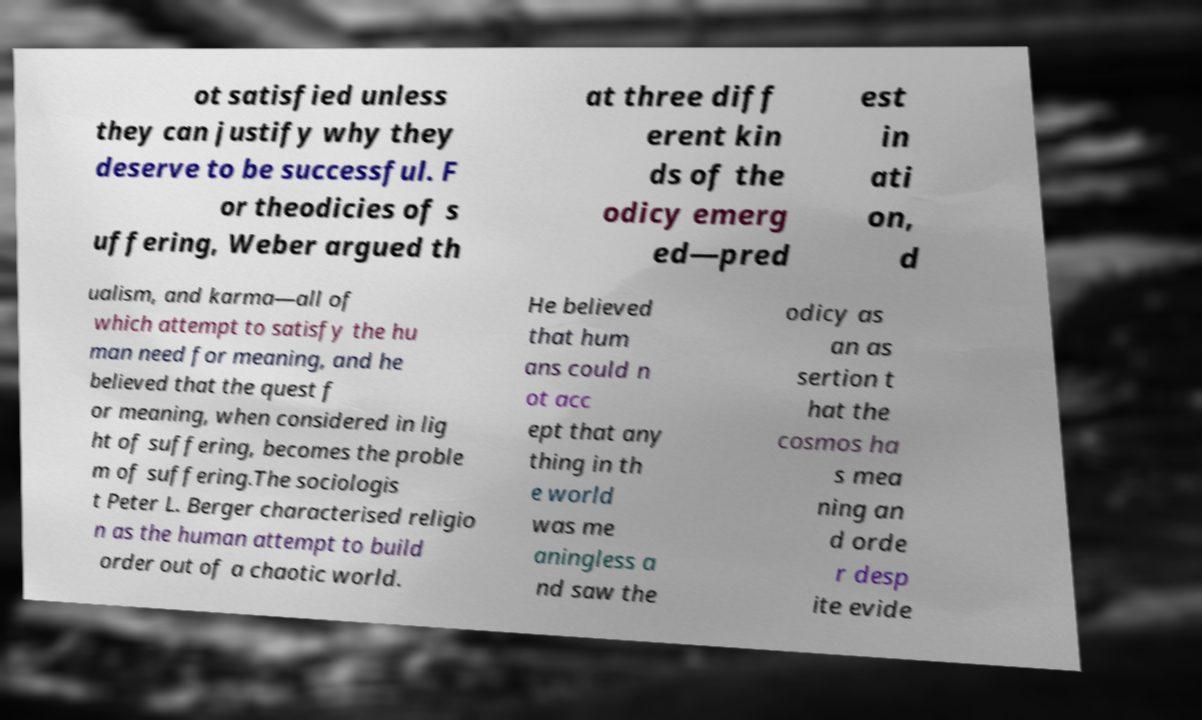Can you accurately transcribe the text from the provided image for me? ot satisfied unless they can justify why they deserve to be successful. F or theodicies of s uffering, Weber argued th at three diff erent kin ds of the odicy emerg ed—pred est in ati on, d ualism, and karma—all of which attempt to satisfy the hu man need for meaning, and he believed that the quest f or meaning, when considered in lig ht of suffering, becomes the proble m of suffering.The sociologis t Peter L. Berger characterised religio n as the human attempt to build order out of a chaotic world. He believed that hum ans could n ot acc ept that any thing in th e world was me aningless a nd saw the odicy as an as sertion t hat the cosmos ha s mea ning an d orde r desp ite evide 